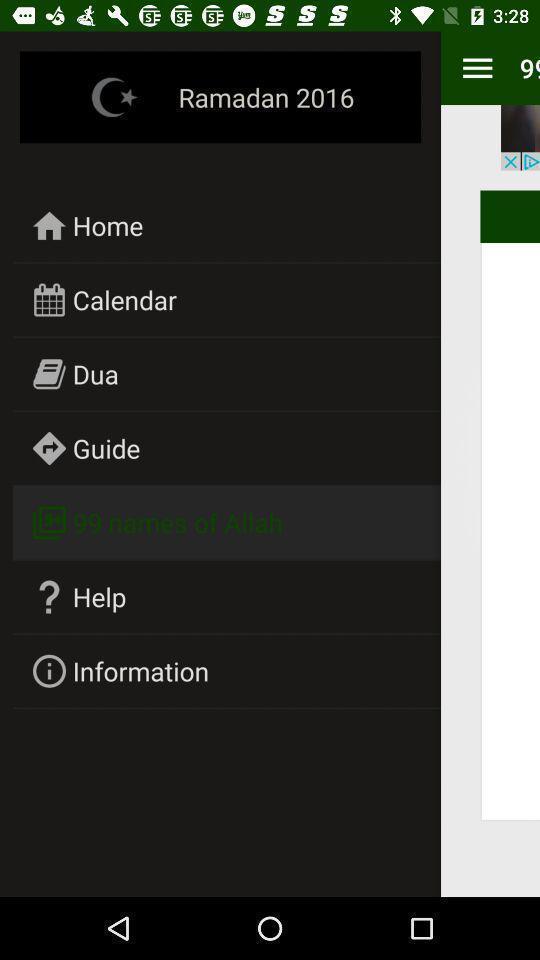Tell me what you see in this picture. Pop-up showing the multiple options. 